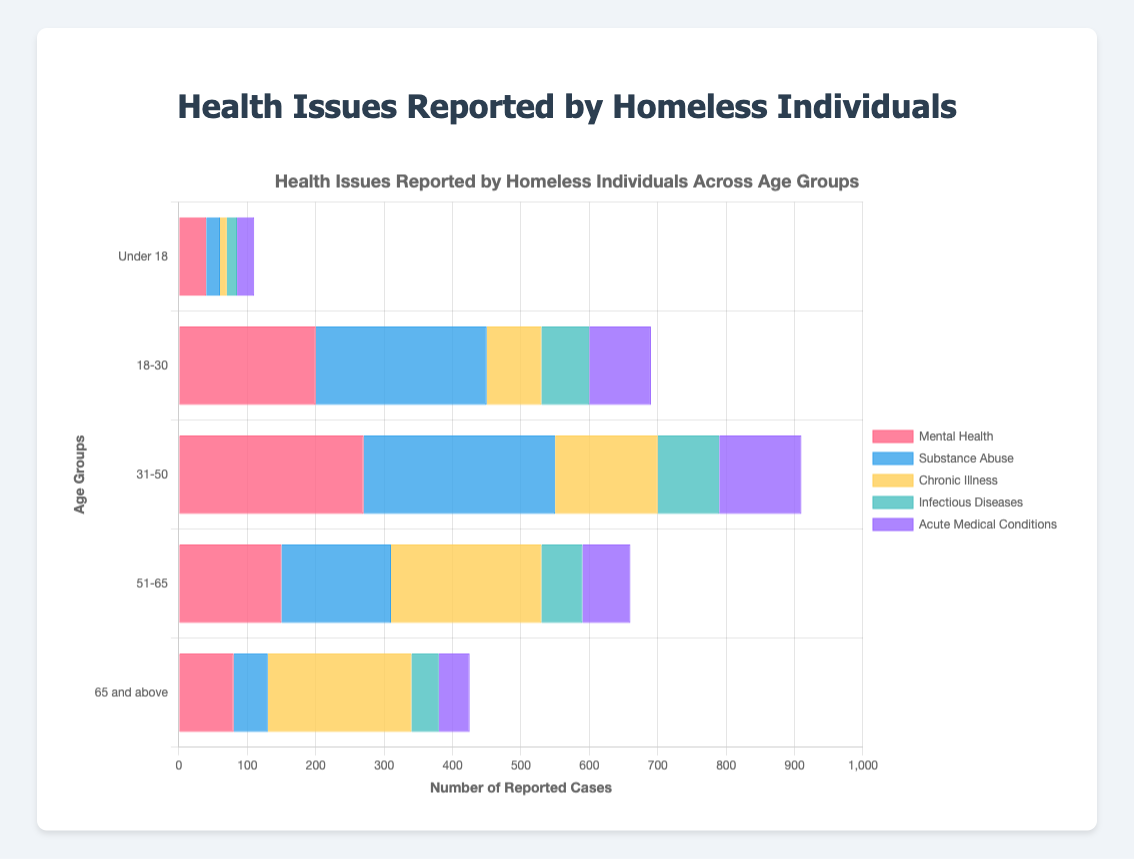What is the most reported health issue among individuals aged 31-50? Look at the bars for the age group 31-50. Identify the tallest bar which corresponds to Substance Abuse with a value of 280.
Answer: Substance Abuse Which age group reports the highest number of chronic illnesses? Compare the bar heights for Chronic Illness across all age groups. The age group 51-65 has the highest value at 220.
Answer: 51-65 Among individuals under 18, which health issue is the least reported? Look at the bars for the age group Under 18 and compare their lengths. Chronic Illness has the shortest bar with a value of 10.
Answer: Chronic Illness How many more Substance Abuse cases are reported by individuals aged 18-30 compared to those aged 65 and above? For Substance Abuse, subtract the number of cases for 65 and above from 18-30: 250 - 50 = 200.
Answer: 200 What is the total number of health issues reported by individuals aged 51-65? Sum up all the values of the bars for the age group 51-65: 150 (Mental Health) + 160 (Substance Abuse) + 220 (Chronic Illness) + 60 (Infectious Diseases) + 70 (Acute Medical Conditions) = 660.
Answer: 660 Which health issue has the most consistent number of cases across all age groups? Examine the variations in the heights of the bars for each health issue across all age groups. Infectious Diseases varies the least from 15 to 70 across all age groups.
Answer: Infectious Diseases Compare the number of Mental Health cases and Substance Abuse cases among individuals aged 31-50. Which is greater and by how much? For 31-50, Mental Health is 270 and Substance Abuse is 280. Substance Abuse is greater by 280 - 270 = 10.
Answer: Substance Abuse by 10 What is the average number of reported Acute Medical Conditions across all age groups? Sum all the Acute Medical Conditions values: 25 (Under 18) + 90 (18-30) + 120 (31-50) + 70 (51-65) + 45 (65 and above) = 350. Divide by the number of age groups: 350 / 5 = 70.
Answer: 70 